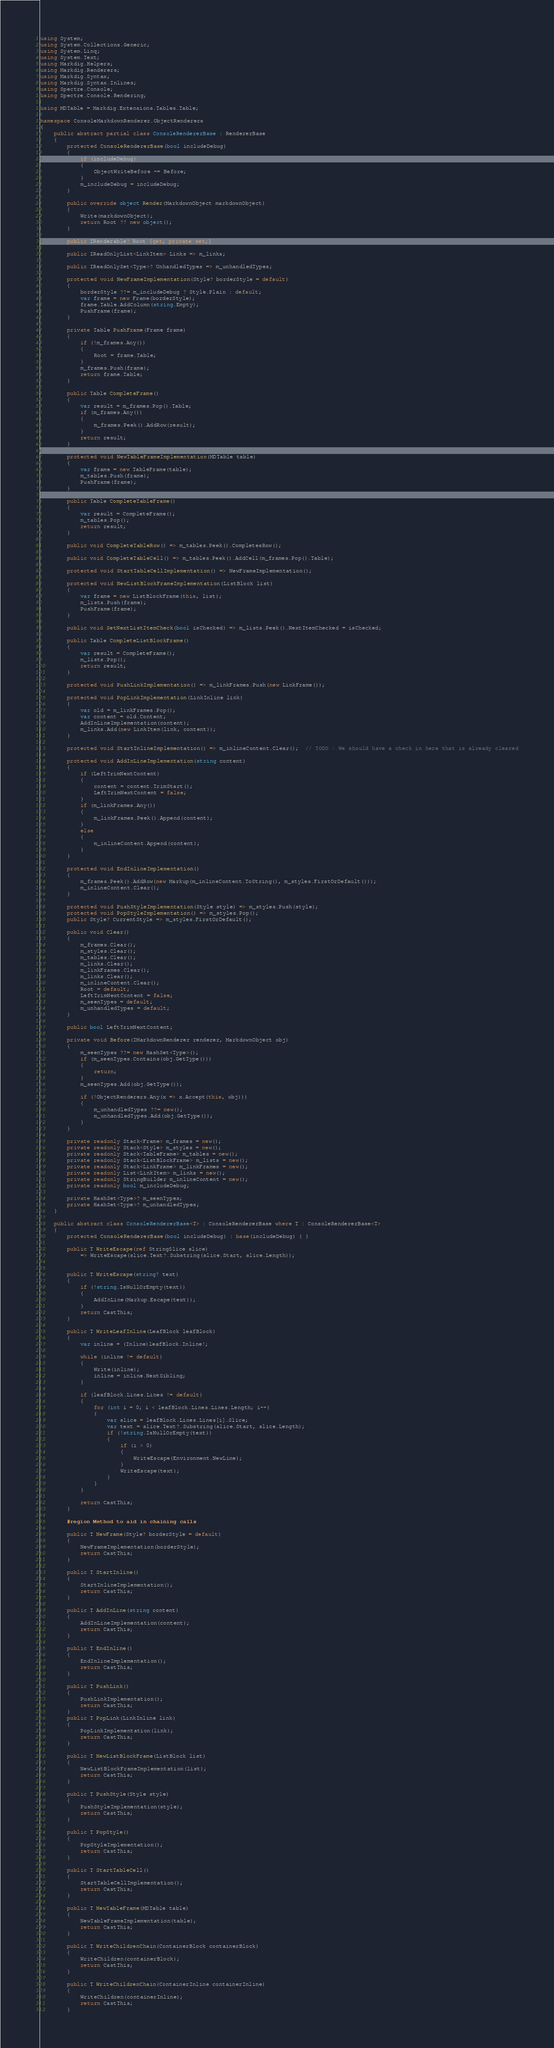Convert code to text. <code><loc_0><loc_0><loc_500><loc_500><_C#_>using System;
using System.Collections.Generic;
using System.Linq;
using System.Text;
using Markdig.Helpers;
using Markdig.Renderers;
using Markdig.Syntax;
using Markdig.Syntax.Inlines;
using Spectre.Console;
using Spectre.Console.Rendering;

using MDTable = Markdig.Extensions.Tables.Table;

namespace ConsoleMarkdownRenderer.ObjectRenderers
{
    public abstract partial class ConsoleRendererBase : RendererBase
    {
        protected ConsoleRendererBase(bool includeDebug)
        {
            if (includeDebug)
            {
                ObjectWriteBefore += Before;
            }
            m_includeDebug = includeDebug;
        }

        public override object Render(MarkdownObject markdownObject)
        {
            Write(markdownObject);
            return Root ?? new object();
        }

        public IRenderable? Root {get; private set;}

        public IReadOnlyList<LinkItem> Links => m_links;

        public IReadOnlySet<Type>? UnhandledTypes => m_unhandledTypes;

        protected void NewFrameImplementation(Style? borderStyle = default)
        {
            borderStyle ??= m_includeDebug ? Style.Plain : default;
            var frame = new Frame(borderStyle);
            frame.Table.AddColumn(string.Empty);
            PushFrame(frame);
        }

        private Table PushFrame(Frame frame)
        {
            if (!m_frames.Any())
            {
                Root = frame.Table;
            }
            m_frames.Push(frame);
            return frame.Table;
        }

        public Table CompleteFrame() 
        {
            var result = m_frames.Pop().Table;
            if (m_frames.Any())
            {
                m_frames.Peek().AddRow(result);
            }
            return result;
        }

        protected void NewTableFrameImplementation(MDTable table)
        {
            var frame = new TableFrame(table);
            m_tables.Push(frame);
            PushFrame(frame);
        }

        public Table CompleteTableFrame()
        {
            var result = CompleteFrame();
            m_tables.Pop();
            return result;
        }

        public void CompleteTableRow() => m_tables.Peek().CompletesRow();

        public void CompleteTableCell() => m_tables.Peek().AddCell(m_frames.Pop().Table);

        protected void StartTableCellImplementation() => NewFrameImplementation();

        protected void NewListBlockFrameImplementation(ListBlock list)
        {
            var frame = new ListBlockFrame(this, list);
            m_lists.Push(frame);
            PushFrame(frame);
        }

        public void SetNextListItemCheck(bool isChecked) => m_lists.Peek().NextItemChecked = isChecked;

        public Table CompleteListBlockFrame()
        {
            var result = CompleteFrame();
            m_lists.Pop();
            return result;
        }

        protected void PushLinkImplementation() => m_linkFrames.Push(new LinkFrame());

        protected void PopLinkImplementation(LinkInline link)
        {
            var old = m_linkFrames.Pop();
            var content = old.Content;
            AddInLineImplementation(content);
            m_links.Add(new LinkItem(link, content));
        }

        protected void StartInlineImplementation() => m_inlineContent.Clear();  // TODO : We should have a check in here that is already cleared

        protected void AddInLineImplementation(string content)
        {
            if (LeftTrimNextContent)
            {
                content = content.TrimStart();
                LeftTrimNextContent = false;
            }
            if (m_linkFrames.Any())
            {
                m_linkFrames.Peek().Append(content);
            }
            else
            {
                m_inlineContent.Append(content);
            }
        }

        protected void EndInlineImplementation()
        {
            m_frames.Peek().AddRow(new Markup(m_inlineContent.ToString(), m_styles.FirstOrDefault()));
            m_inlineContent.Clear();
        }

        protected void PushStyleImplementation(Style style) => m_styles.Push(style);
        protected void PopStyleImplementation() => m_styles.Pop();
        public Style? CurrentStyle => m_styles.FirstOrDefault();

        public void Clear()
        {
            m_frames.Clear();
            m_styles.Clear();
            m_tables.Clear();
            m_links.Clear();
            m_linkFrames.Clear();
            m_links.Clear();
            m_inlineContent.Clear();
            Root = default;
            LeftTrimNextContent = false;
            m_seenTypes = default;
            m_unhandledTypes = default;
        }

        public bool LeftTrimNextContent;

        private void Before(IMarkdownRenderer renderer, MarkdownObject obj)
        {
            m_seenTypes ??= new HashSet<Type>();
            if (m_seenTypes.Contains(obj.GetType()))
            {
                return;
            }
            m_seenTypes.Add(obj.GetType());

            if (!ObjectRenderers.Any(x => x.Accept(this, obj)))
            {
                m_unhandledTypes ??= new();
                m_unhandledTypes.Add(obj.GetType());
            }
        }

        private readonly Stack<Frame> m_frames = new();
        private readonly Stack<Style> m_styles = new();
        private readonly Stack<TableFrame> m_tables = new();
        private readonly Stack<ListBlockFrame> m_lists = new();
        private readonly Stack<LinkFrame> m_linkFrames = new();
        private readonly List<LinkItem> m_links = new();
        private readonly StringBuilder m_inlineContent = new();
        private readonly bool m_includeDebug;

        private HashSet<Type>? m_seenTypes;
        private HashSet<Type>? m_unhandledTypes;
    }

    public abstract class ConsoleRendererBase<T> : ConsoleRendererBase where T : ConsoleRendererBase<T>
    {
        protected ConsoleRendererBase(bool includeDebug) : base(includeDebug) { }

        public T WriteEscape(ref StringSlice slice) 
            => WriteEscape(slice.Text?.Substring(slice.Start, slice.Length));


        public T WriteEscape(string? text)
        {
            if (!string.IsNullOrEmpty(text))
            {
                AddInLine(Markup.Escape(text));
            }
            return CastThis;
        }

        public T WriteLeafInline(LeafBlock leafBlock)
        {
            var inline = (Inline)leafBlock.Inline!;
          
            while (inline != default)
            {
                Write(inline);
                inline = inline.NextSibling;
            }

            if (leafBlock.Lines.Lines != default)
            {
                for (int i = 0; i < leafBlock.Lines.Lines.Length; i++)
                {
                    var slice = leafBlock.Lines.Lines[i].Slice;
                    var text = slice.Text?.Substring(slice.Start, slice.Length);
                    if (!string.IsNullOrEmpty(text))
                    {
                        if (i > 0)
                        {
                            WriteEscape(Environment.NewLine);
                        }
                        WriteEscape(text);
                    }
                }
            }
            
            return CastThis;
        }

        #region Method to aid in chaining calls

        public T NewFrame(Style? borderStyle = default)
        {
            NewFrameImplementation(borderStyle);
            return CastThis;
        }

        public T StartInline()
        {
            StartInlineImplementation();
            return CastThis;
        }

        public T AddInLine(string content)
        {
            AddInLineImplementation(content);
            return CastThis;
        }

        public T EndInline()
        {
            EndInlineImplementation();
            return CastThis;
        }

        public T PushLink()
        {
            PushLinkImplementation();
            return CastThis;
        }
        public T PopLink(LinkInline link)
        {
            PopLinkImplementation(link);
            return CastThis;
        }

        public T NewListBlockFrame(ListBlock list)
        {
            NewListBlockFrameImplementation(list);
            return CastThis;
        }

        public T PushStyle(Style style)
        {
            PushStyleImplementation(style);
            return CastThis;
        }

        public T PopStyle()
        {
            PopStyleImplementation();
            return CastThis;
        }

        public T StartTableCell()
        {
            StartTableCellImplementation();
            return CastThis;
        } 

        public T NewTableFrame(MDTable table)
        {
            NewTableFrameImplementation(table);
            return CastThis;
        }

        public T WriteChildrenChain(ContainerBlock containerBlock)
        {
            WriteChildren(containerBlock);
            return CastThis;
        }

        public T WriteChildrenChain(ContainerInline containerInline)
        {
            WriteChildren(containerInline);
            return CastThis;
        }
</code> 